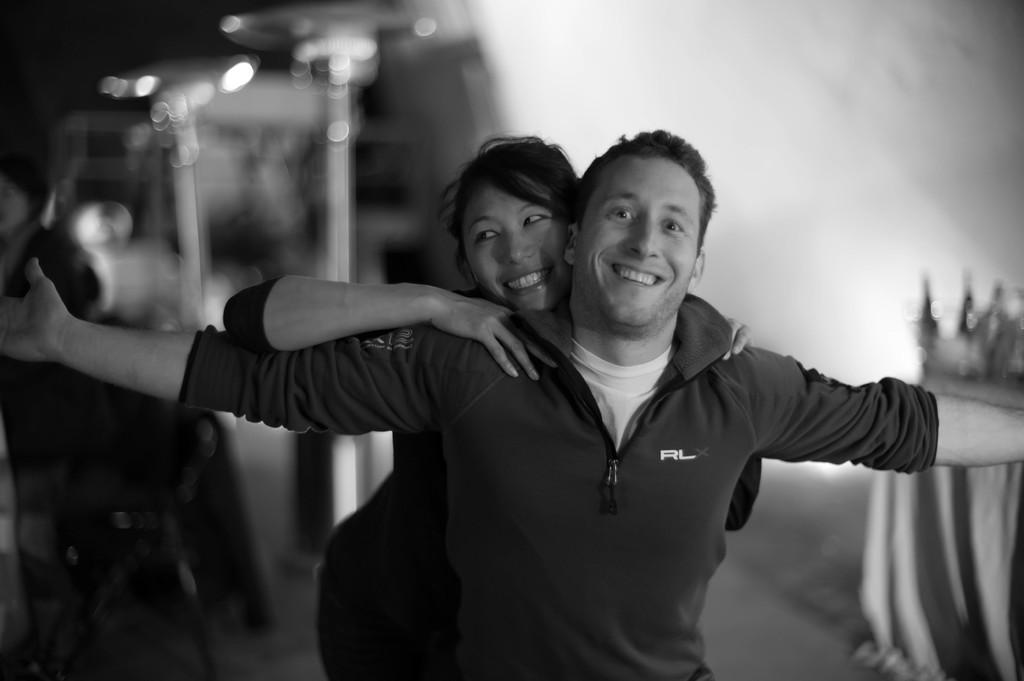What are the two people in the image doing? Both the man and the woman are smiling in the image. Can you describe the appearance of the two people? There is a man and a woman in the image. What is the condition of the background in the image? The background of the image is blurry. What type of yarn is the man using to stretch in the image? There is no yarn or stretching activity present in the image. Are the two people in the image sisters? The provided facts do not mention any familial relationship between the man and the woman in the image. 